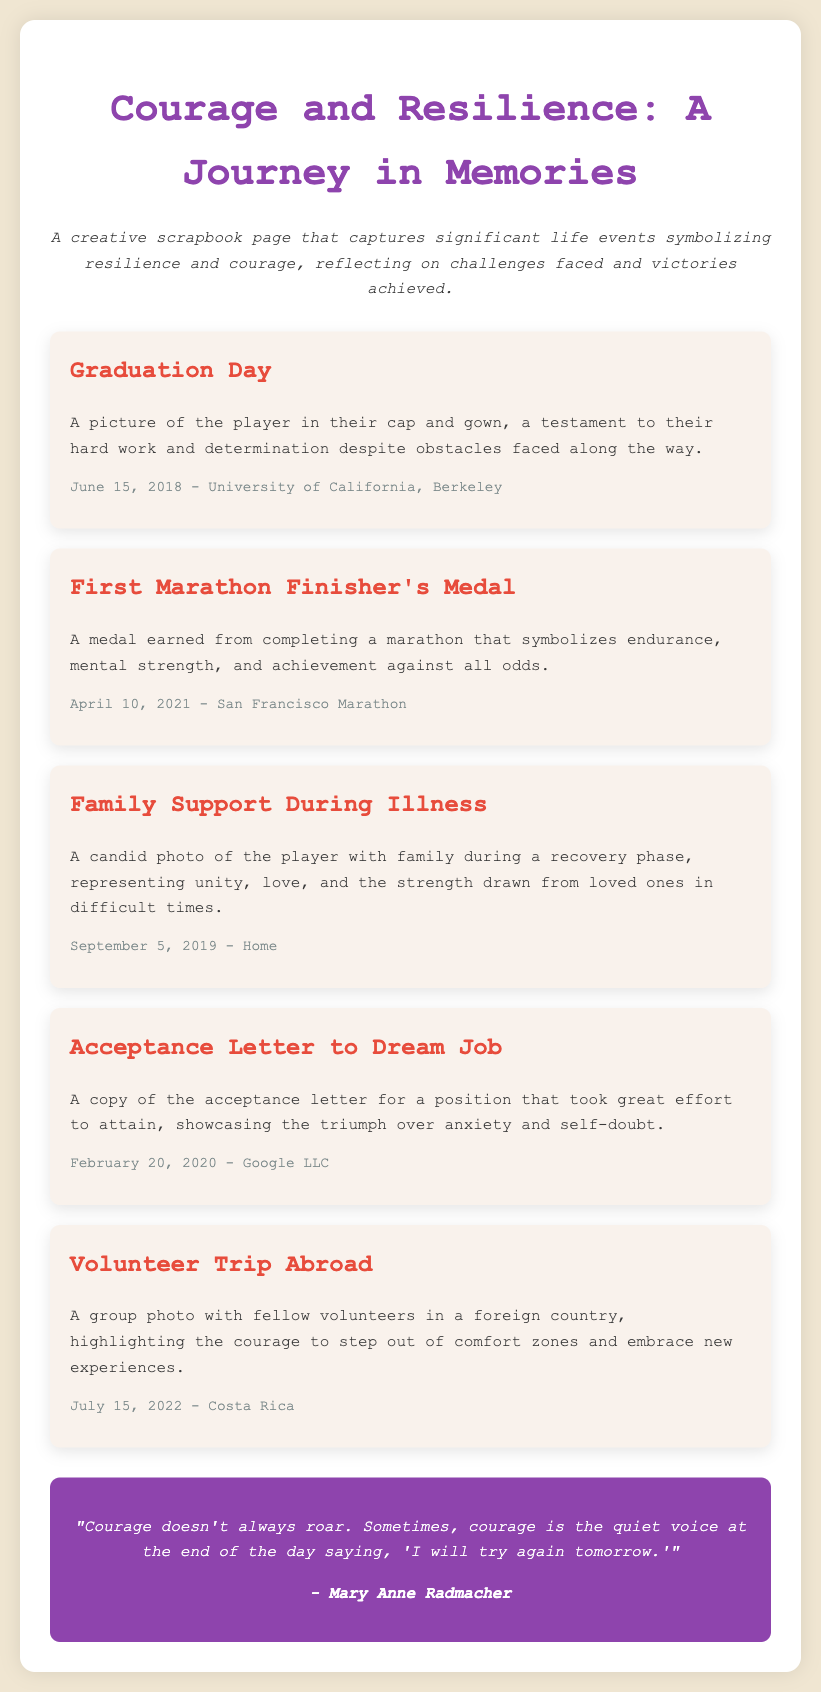What is the title of the document? The title is presented at the top of the document as a heading, which is "Courage and Resilience: A Journey in Memories."
Answer: Courage and Resilience: A Journey in Memories What symbolizes endurance in the scrapbook? The scrapbook includes significant items, one of which is "First Marathon Finisher's Medal," representing endurance.
Answer: First Marathon Finisher's Medal When was the graduation day? The date of graduation is mentioned along with the event details in the corresponding section, which is June 15, 2018.
Answer: June 15, 2018 Who is the author of the quote featured in the scrapbook? The quote at the end attributes its authorship, which is mentioned as being by Mary Anne Radmacher.
Answer: Mary Anne Radmacher What event does the photo of family support relate to? The document specifies the event related to family support as "Family Support During Illness."
Answer: Family Support During Illness How many memory items are listed in the document? The total number of memory items can be counted from the sections provided; there are five memory items.
Answer: 5 What is the location of the volunteer trip abroad? The location for the volunteer trip is specified in the memory item as Costa Rica.
Answer: Costa Rica What does the acceptance letter symbolize? The acceptance letter represents triumph over anxiety and self-doubt, as outlined in the relevant section.
Answer: Triumph over anxiety and self-doubt What is the overarching theme of the scrapbook? The description at the top highlights that it captures significant life events symbolizing resilience and courage.
Answer: Resilience and courage 